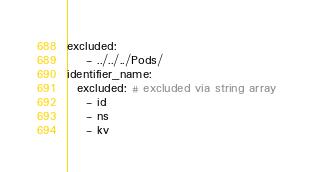<code> <loc_0><loc_0><loc_500><loc_500><_YAML_>excluded:
    - ../../../Pods/
identifier_name:
  excluded: # excluded via string array
    - id
    - ns
    - kv
</code> 